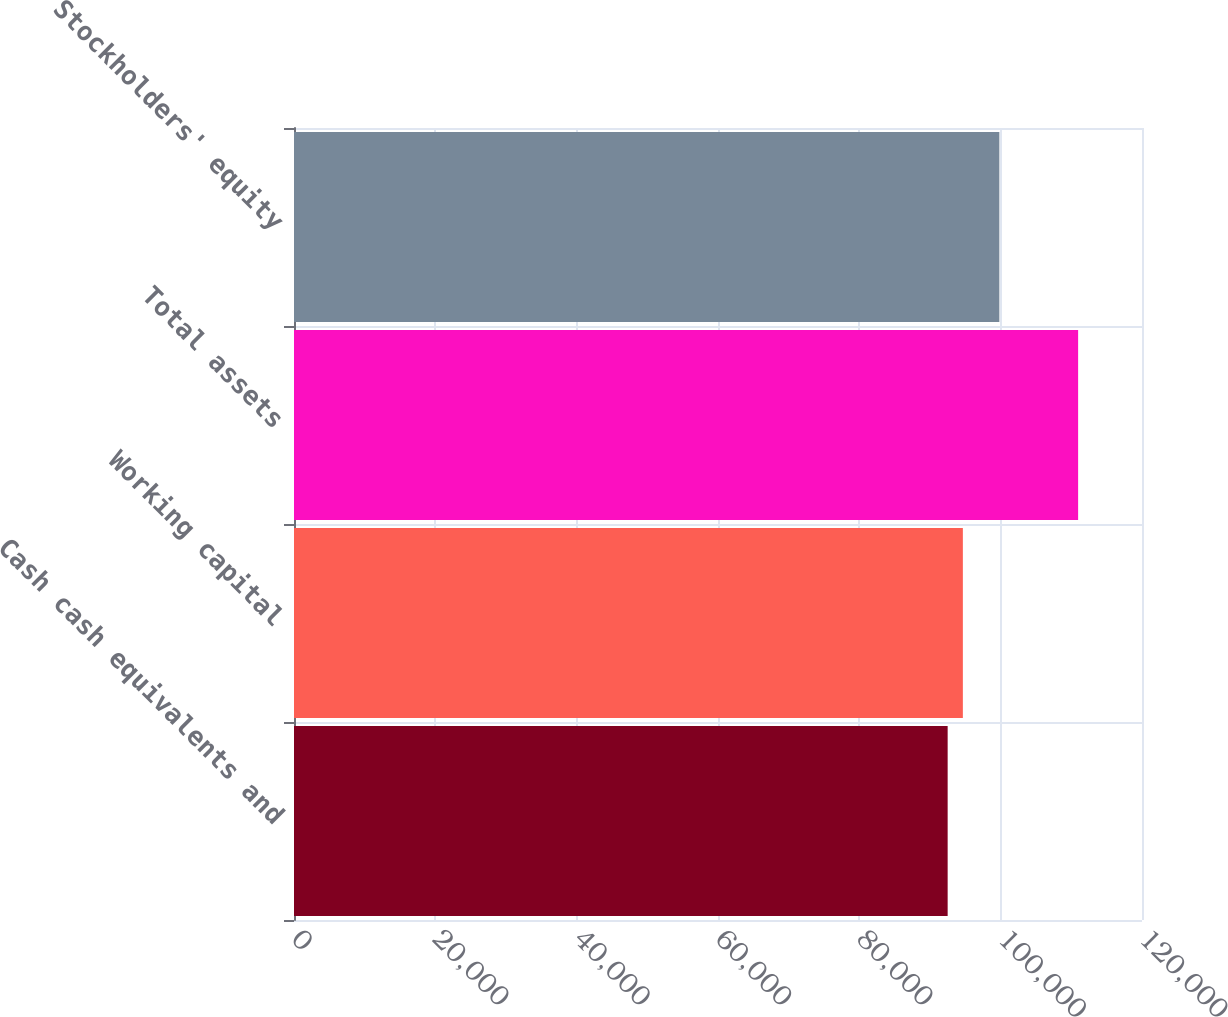Convert chart to OTSL. <chart><loc_0><loc_0><loc_500><loc_500><bar_chart><fcel>Cash cash equivalents and<fcel>Working capital<fcel>Total assets<fcel>Stockholders' equity<nl><fcel>92498<fcel>94651<fcel>110961<fcel>99814<nl></chart> 